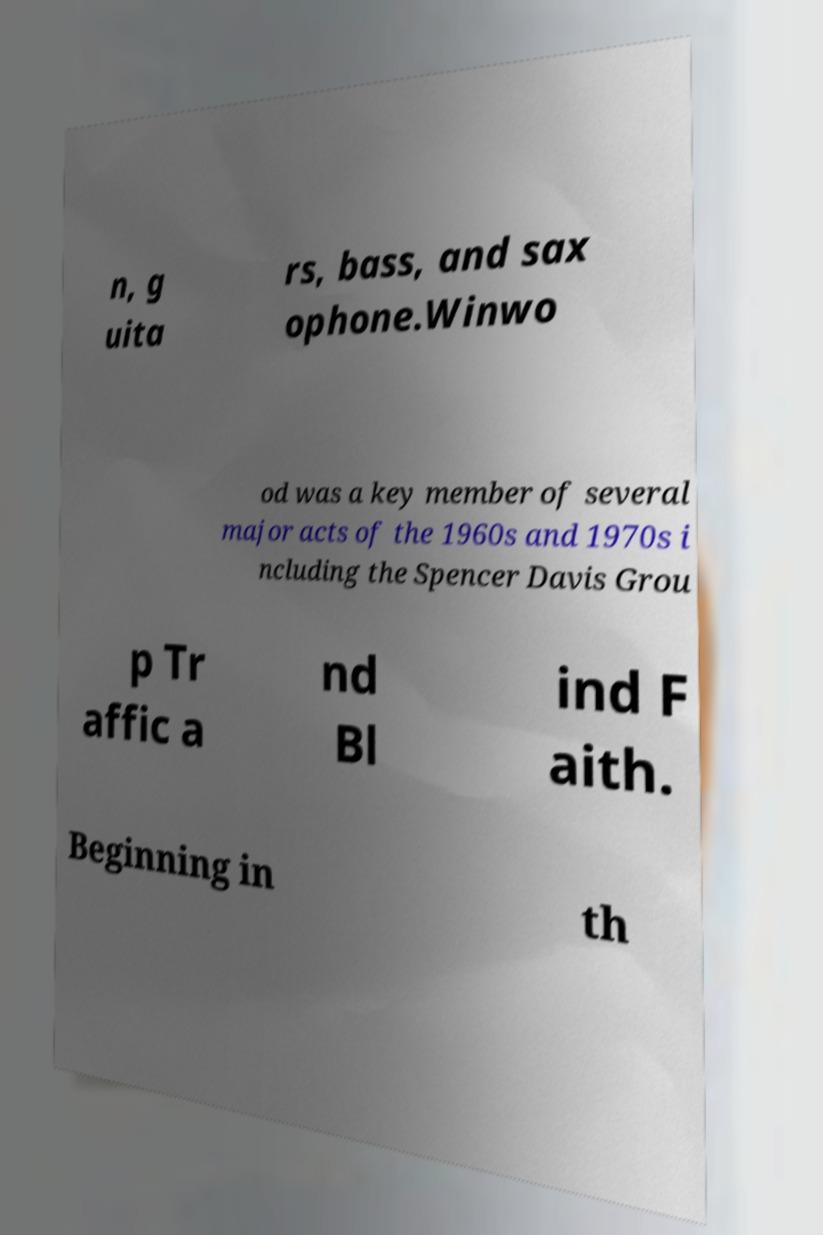Can you accurately transcribe the text from the provided image for me? n, g uita rs, bass, and sax ophone.Winwo od was a key member of several major acts of the 1960s and 1970s i ncluding the Spencer Davis Grou p Tr affic a nd Bl ind F aith. Beginning in th 